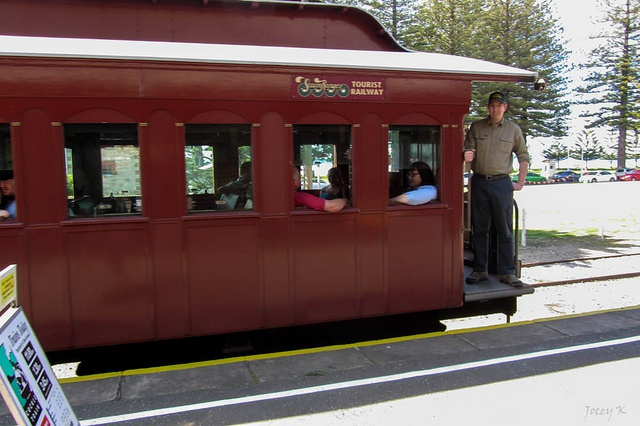Describe the objects in this image and their specific colors. I can see train in maroon, black, white, and gray tones, people in maroon, black, and gray tones, people in maroon, black, lightblue, darkgray, and gray tones, people in maroon, brown, and black tones, and people in maroon, black, gray, and darkblue tones in this image. 